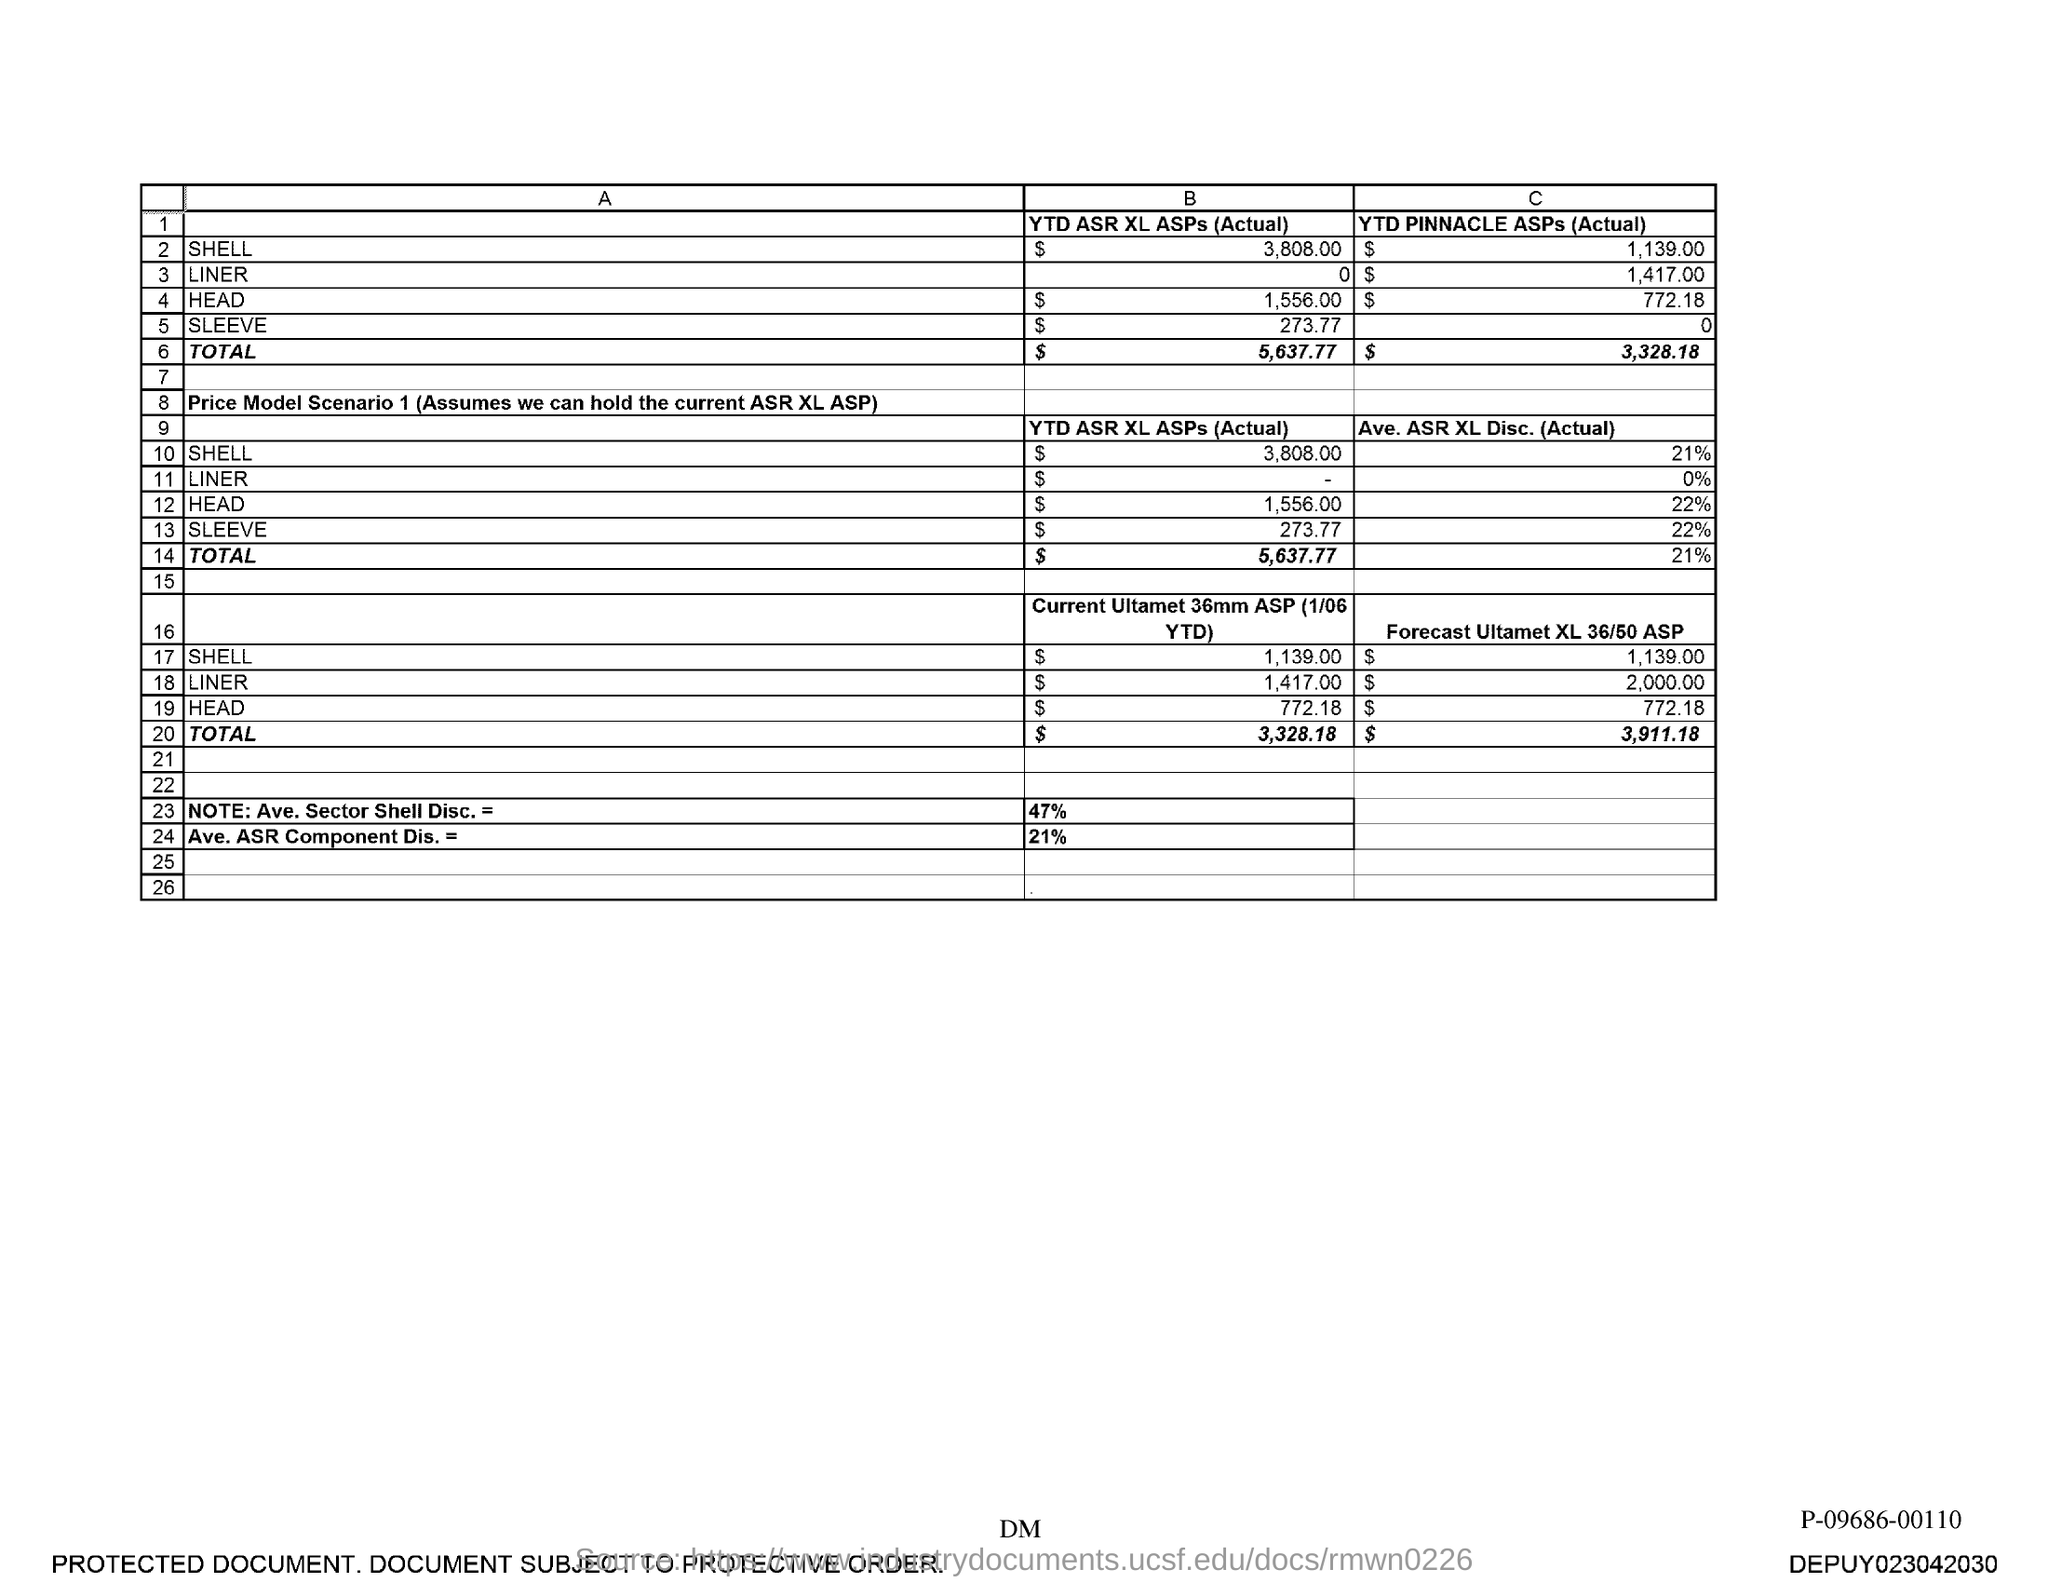Indicate a few pertinent items in this graphic. As of today, the year-to-date (YTD) Pinnacle ASPs for Head are $772.18. On a year-to-date (YTD) basis, the actual Actual Safe Working Depth (ASWD) values for Liner are $1,417.00. The total average ASR (Actual) for XL Disc is 21%. The average actual performance of Shell's XL Disc is 21%. The average actual surface roughness (ASR) for the liner is 0%. 